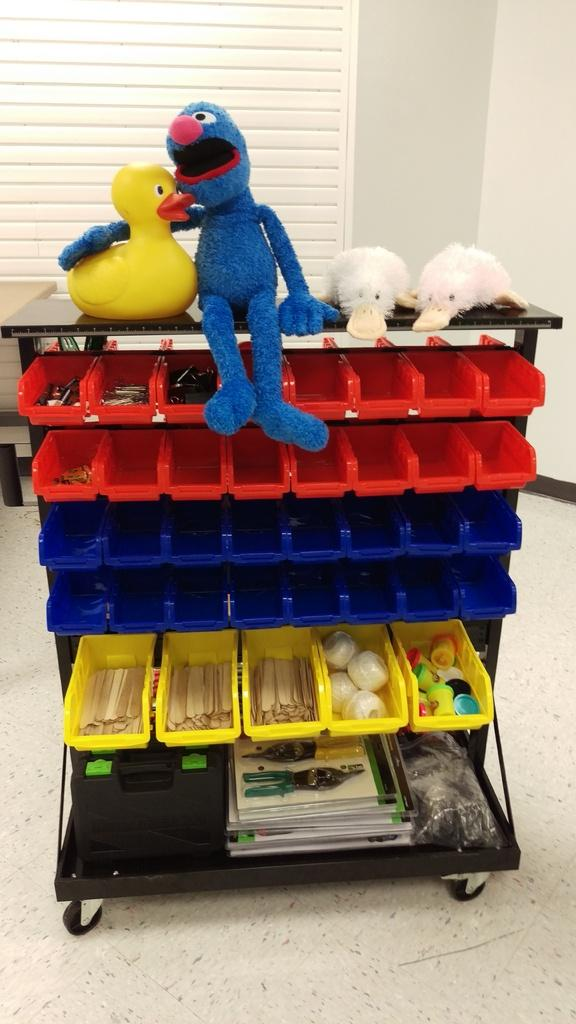What type of objects can be seen in the image? There are toys in the image. Can you describe the arrangement of objects in the image? There is a rack with objects arranged in it. What type of protest is taking place in the image? There is no protest present in the image; it features toys and a rack with objects arranged in it. Can you see a minister in the image? There is no minister present in the image. 